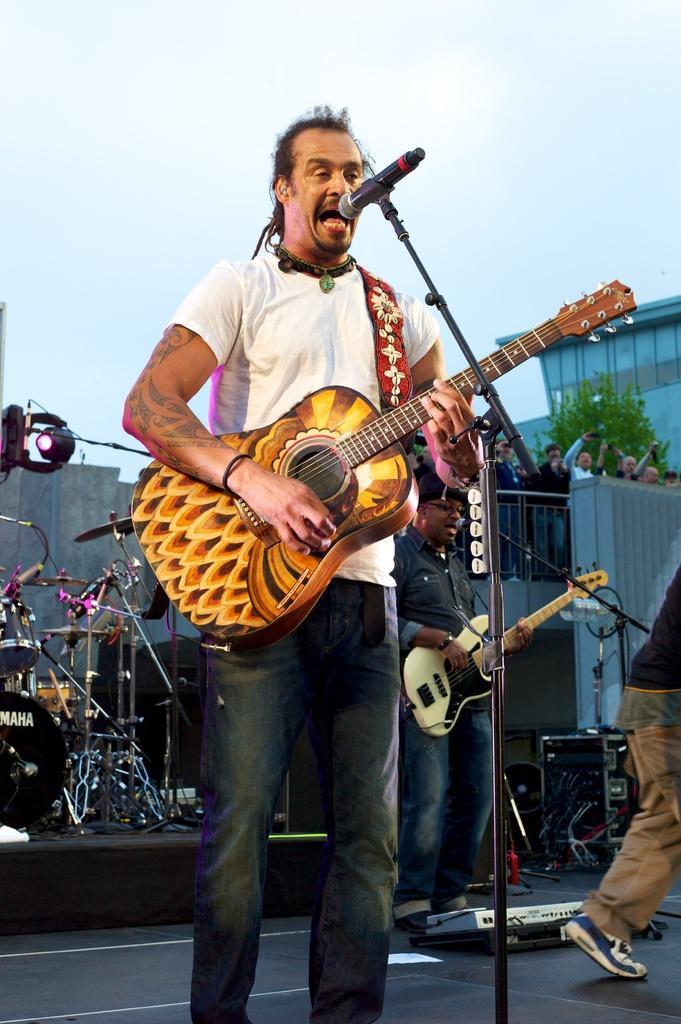Please provide a concise description of this image. In this image we can see some people standing on the ground. Two men are holding guitars in their hands. In the foreground of the image we can see microphone placed on a stand, a device placed on the ground. On the left side of the image we can see some musical instruments and a light. On the right side of the image we can see some cables, barricade, tree and a building. At the top of the image we can see the sky. 